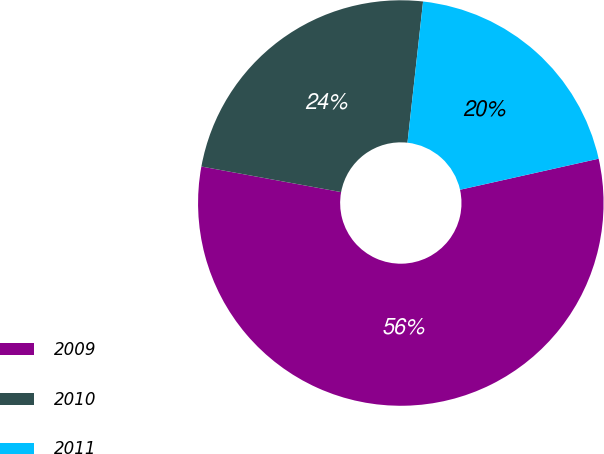Convert chart. <chart><loc_0><loc_0><loc_500><loc_500><pie_chart><fcel>2009<fcel>2010<fcel>2011<nl><fcel>56.39%<fcel>23.87%<fcel>19.74%<nl></chart> 